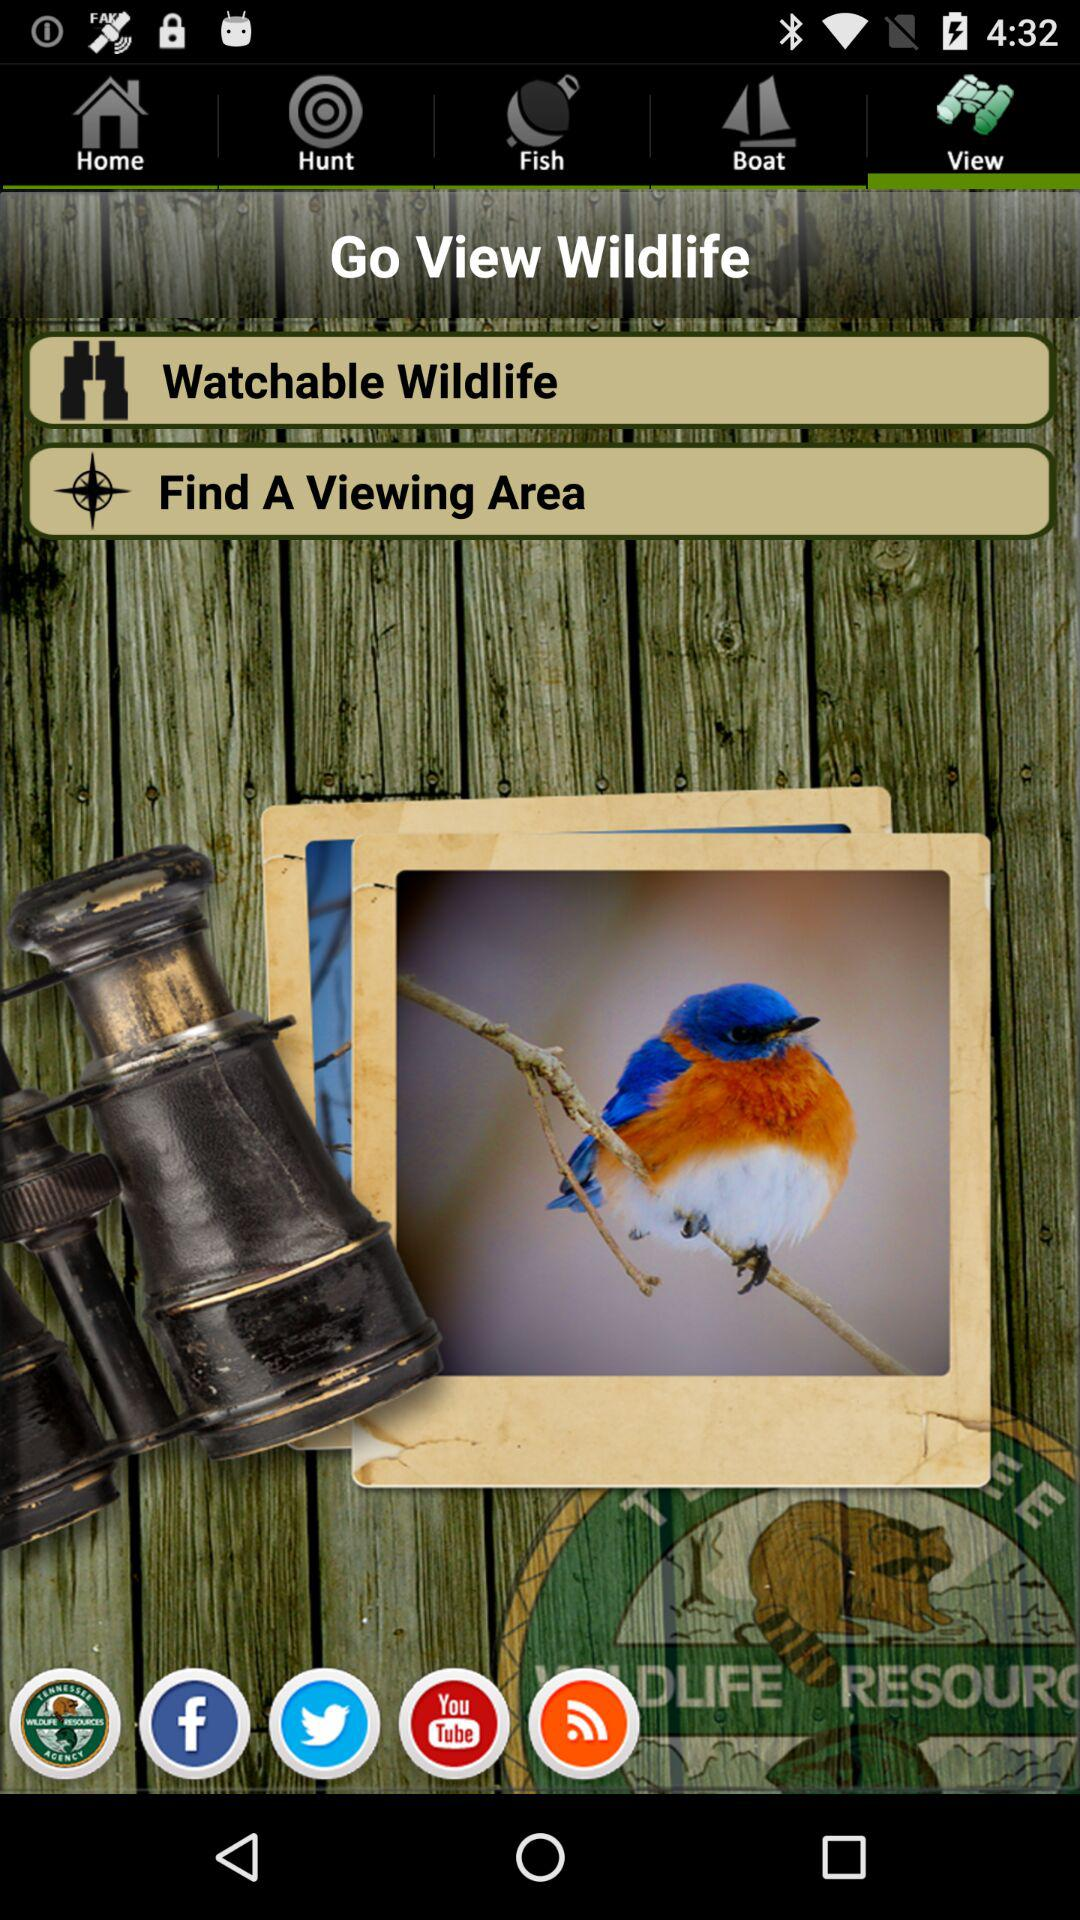Which tab is selected? The selected tab is "View". 